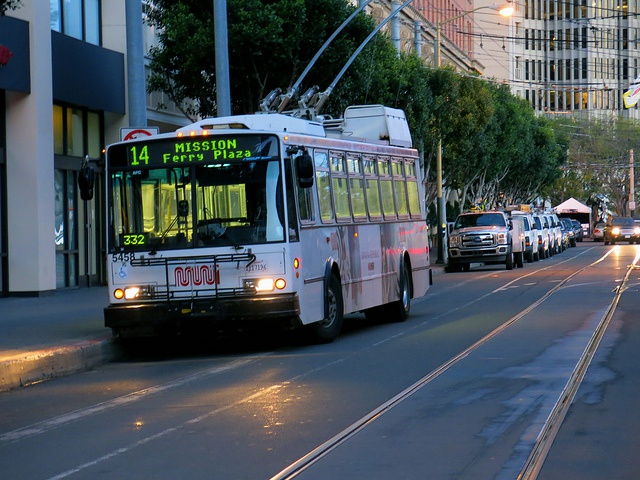Describe the objects in this image and their specific colors. I can see bus in black, gray, and darkgray tones, truck in black, gray, blue, and darkgray tones, car in black, gray, white, and maroon tones, car in black, lavender, darkgray, and lightblue tones, and car in black, lightgray, darkgray, and lightblue tones in this image. 